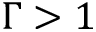<formula> <loc_0><loc_0><loc_500><loc_500>\Gamma > 1</formula> 